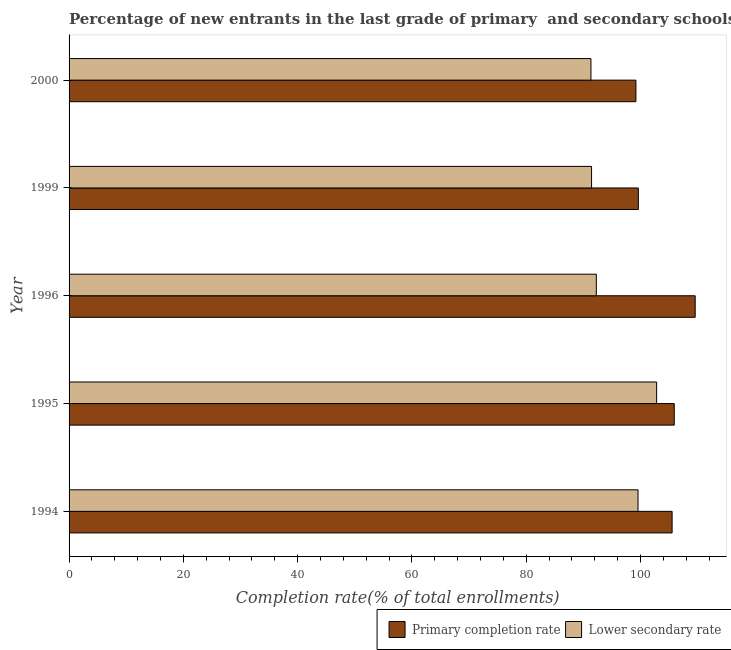How many different coloured bars are there?
Your answer should be compact. 2. Are the number of bars per tick equal to the number of legend labels?
Offer a very short reply. Yes. Are the number of bars on each tick of the Y-axis equal?
Offer a terse response. Yes. What is the label of the 1st group of bars from the top?
Your answer should be very brief. 2000. What is the completion rate in secondary schools in 1996?
Provide a succinct answer. 92.26. Across all years, what is the maximum completion rate in primary schools?
Ensure brevity in your answer.  109.56. Across all years, what is the minimum completion rate in secondary schools?
Offer a terse response. 91.32. In which year was the completion rate in secondary schools maximum?
Your answer should be compact. 1995. What is the total completion rate in primary schools in the graph?
Offer a terse response. 519.78. What is the difference between the completion rate in secondary schools in 1995 and that in 1999?
Ensure brevity in your answer.  11.38. What is the difference between the completion rate in secondary schools in 2000 and the completion rate in primary schools in 1994?
Your response must be concise. -14.2. What is the average completion rate in secondary schools per year?
Your answer should be compact. 95.48. In the year 2000, what is the difference between the completion rate in secondary schools and completion rate in primary schools?
Your response must be concise. -7.87. In how many years, is the completion rate in primary schools greater than 12 %?
Your answer should be very brief. 5. What is the ratio of the completion rate in primary schools in 1999 to that in 2000?
Provide a succinct answer. 1. Is the difference between the completion rate in primary schools in 1994 and 1996 greater than the difference between the completion rate in secondary schools in 1994 and 1996?
Make the answer very short. No. What is the difference between the highest and the second highest completion rate in primary schools?
Your response must be concise. 3.66. What is the difference between the highest and the lowest completion rate in secondary schools?
Provide a short and direct response. 11.49. Is the sum of the completion rate in secondary schools in 1994 and 2000 greater than the maximum completion rate in primary schools across all years?
Your answer should be compact. Yes. What does the 2nd bar from the top in 1996 represents?
Your response must be concise. Primary completion rate. What does the 2nd bar from the bottom in 1999 represents?
Ensure brevity in your answer.  Lower secondary rate. What is the difference between two consecutive major ticks on the X-axis?
Your answer should be compact. 20. Are the values on the major ticks of X-axis written in scientific E-notation?
Your answer should be very brief. No. Does the graph contain any zero values?
Offer a very short reply. No. Does the graph contain grids?
Your answer should be very brief. No. Where does the legend appear in the graph?
Offer a very short reply. Bottom right. How many legend labels are there?
Offer a terse response. 2. How are the legend labels stacked?
Provide a short and direct response. Horizontal. What is the title of the graph?
Provide a short and direct response. Percentage of new entrants in the last grade of primary  and secondary schools in Czech Republic. What is the label or title of the X-axis?
Keep it short and to the point. Completion rate(% of total enrollments). What is the label or title of the Y-axis?
Offer a terse response. Year. What is the Completion rate(% of total enrollments) in Primary completion rate in 1994?
Provide a succinct answer. 105.52. What is the Completion rate(% of total enrollments) in Lower secondary rate in 1994?
Your response must be concise. 99.56. What is the Completion rate(% of total enrollments) in Primary completion rate in 1995?
Ensure brevity in your answer.  105.9. What is the Completion rate(% of total enrollments) of Lower secondary rate in 1995?
Your response must be concise. 102.81. What is the Completion rate(% of total enrollments) in Primary completion rate in 1996?
Provide a succinct answer. 109.56. What is the Completion rate(% of total enrollments) of Lower secondary rate in 1996?
Keep it short and to the point. 92.26. What is the Completion rate(% of total enrollments) of Primary completion rate in 1999?
Provide a succinct answer. 99.61. What is the Completion rate(% of total enrollments) of Lower secondary rate in 1999?
Offer a very short reply. 91.43. What is the Completion rate(% of total enrollments) of Primary completion rate in 2000?
Give a very brief answer. 99.19. What is the Completion rate(% of total enrollments) in Lower secondary rate in 2000?
Give a very brief answer. 91.32. Across all years, what is the maximum Completion rate(% of total enrollments) in Primary completion rate?
Offer a terse response. 109.56. Across all years, what is the maximum Completion rate(% of total enrollments) of Lower secondary rate?
Provide a succinct answer. 102.81. Across all years, what is the minimum Completion rate(% of total enrollments) of Primary completion rate?
Your response must be concise. 99.19. Across all years, what is the minimum Completion rate(% of total enrollments) in Lower secondary rate?
Ensure brevity in your answer.  91.32. What is the total Completion rate(% of total enrollments) of Primary completion rate in the graph?
Your answer should be very brief. 519.78. What is the total Completion rate(% of total enrollments) in Lower secondary rate in the graph?
Make the answer very short. 477.38. What is the difference between the Completion rate(% of total enrollments) of Primary completion rate in 1994 and that in 1995?
Make the answer very short. -0.38. What is the difference between the Completion rate(% of total enrollments) in Lower secondary rate in 1994 and that in 1995?
Your answer should be very brief. -3.25. What is the difference between the Completion rate(% of total enrollments) in Primary completion rate in 1994 and that in 1996?
Offer a very short reply. -4.04. What is the difference between the Completion rate(% of total enrollments) in Lower secondary rate in 1994 and that in 1996?
Make the answer very short. 7.3. What is the difference between the Completion rate(% of total enrollments) of Primary completion rate in 1994 and that in 1999?
Provide a short and direct response. 5.91. What is the difference between the Completion rate(% of total enrollments) of Lower secondary rate in 1994 and that in 1999?
Provide a succinct answer. 8.13. What is the difference between the Completion rate(% of total enrollments) of Primary completion rate in 1994 and that in 2000?
Provide a succinct answer. 6.33. What is the difference between the Completion rate(% of total enrollments) of Lower secondary rate in 1994 and that in 2000?
Keep it short and to the point. 8.24. What is the difference between the Completion rate(% of total enrollments) of Primary completion rate in 1995 and that in 1996?
Offer a terse response. -3.66. What is the difference between the Completion rate(% of total enrollments) of Lower secondary rate in 1995 and that in 1996?
Offer a very short reply. 10.55. What is the difference between the Completion rate(% of total enrollments) of Primary completion rate in 1995 and that in 1999?
Keep it short and to the point. 6.29. What is the difference between the Completion rate(% of total enrollments) of Lower secondary rate in 1995 and that in 1999?
Offer a terse response. 11.38. What is the difference between the Completion rate(% of total enrollments) of Primary completion rate in 1995 and that in 2000?
Provide a short and direct response. 6.71. What is the difference between the Completion rate(% of total enrollments) of Lower secondary rate in 1995 and that in 2000?
Keep it short and to the point. 11.49. What is the difference between the Completion rate(% of total enrollments) of Primary completion rate in 1996 and that in 1999?
Make the answer very short. 9.95. What is the difference between the Completion rate(% of total enrollments) of Lower secondary rate in 1996 and that in 1999?
Your answer should be very brief. 0.83. What is the difference between the Completion rate(% of total enrollments) of Primary completion rate in 1996 and that in 2000?
Your answer should be very brief. 10.37. What is the difference between the Completion rate(% of total enrollments) of Lower secondary rate in 1996 and that in 2000?
Offer a terse response. 0.94. What is the difference between the Completion rate(% of total enrollments) in Primary completion rate in 1999 and that in 2000?
Give a very brief answer. 0.42. What is the difference between the Completion rate(% of total enrollments) of Lower secondary rate in 1999 and that in 2000?
Your answer should be very brief. 0.11. What is the difference between the Completion rate(% of total enrollments) in Primary completion rate in 1994 and the Completion rate(% of total enrollments) in Lower secondary rate in 1995?
Make the answer very short. 2.71. What is the difference between the Completion rate(% of total enrollments) of Primary completion rate in 1994 and the Completion rate(% of total enrollments) of Lower secondary rate in 1996?
Your answer should be very brief. 13.26. What is the difference between the Completion rate(% of total enrollments) of Primary completion rate in 1994 and the Completion rate(% of total enrollments) of Lower secondary rate in 1999?
Your response must be concise. 14.09. What is the difference between the Completion rate(% of total enrollments) of Primary completion rate in 1994 and the Completion rate(% of total enrollments) of Lower secondary rate in 2000?
Make the answer very short. 14.2. What is the difference between the Completion rate(% of total enrollments) of Primary completion rate in 1995 and the Completion rate(% of total enrollments) of Lower secondary rate in 1996?
Offer a terse response. 13.64. What is the difference between the Completion rate(% of total enrollments) of Primary completion rate in 1995 and the Completion rate(% of total enrollments) of Lower secondary rate in 1999?
Make the answer very short. 14.47. What is the difference between the Completion rate(% of total enrollments) of Primary completion rate in 1995 and the Completion rate(% of total enrollments) of Lower secondary rate in 2000?
Your answer should be very brief. 14.58. What is the difference between the Completion rate(% of total enrollments) in Primary completion rate in 1996 and the Completion rate(% of total enrollments) in Lower secondary rate in 1999?
Keep it short and to the point. 18.13. What is the difference between the Completion rate(% of total enrollments) in Primary completion rate in 1996 and the Completion rate(% of total enrollments) in Lower secondary rate in 2000?
Your answer should be very brief. 18.24. What is the difference between the Completion rate(% of total enrollments) in Primary completion rate in 1999 and the Completion rate(% of total enrollments) in Lower secondary rate in 2000?
Make the answer very short. 8.29. What is the average Completion rate(% of total enrollments) in Primary completion rate per year?
Provide a succinct answer. 103.96. What is the average Completion rate(% of total enrollments) of Lower secondary rate per year?
Provide a succinct answer. 95.48. In the year 1994, what is the difference between the Completion rate(% of total enrollments) in Primary completion rate and Completion rate(% of total enrollments) in Lower secondary rate?
Keep it short and to the point. 5.96. In the year 1995, what is the difference between the Completion rate(% of total enrollments) of Primary completion rate and Completion rate(% of total enrollments) of Lower secondary rate?
Make the answer very short. 3.09. In the year 1996, what is the difference between the Completion rate(% of total enrollments) in Primary completion rate and Completion rate(% of total enrollments) in Lower secondary rate?
Provide a succinct answer. 17.3. In the year 1999, what is the difference between the Completion rate(% of total enrollments) in Primary completion rate and Completion rate(% of total enrollments) in Lower secondary rate?
Your response must be concise. 8.18. In the year 2000, what is the difference between the Completion rate(% of total enrollments) of Primary completion rate and Completion rate(% of total enrollments) of Lower secondary rate?
Your answer should be compact. 7.87. What is the ratio of the Completion rate(% of total enrollments) in Primary completion rate in 1994 to that in 1995?
Provide a succinct answer. 1. What is the ratio of the Completion rate(% of total enrollments) of Lower secondary rate in 1994 to that in 1995?
Provide a succinct answer. 0.97. What is the ratio of the Completion rate(% of total enrollments) in Primary completion rate in 1994 to that in 1996?
Ensure brevity in your answer.  0.96. What is the ratio of the Completion rate(% of total enrollments) of Lower secondary rate in 1994 to that in 1996?
Offer a terse response. 1.08. What is the ratio of the Completion rate(% of total enrollments) in Primary completion rate in 1994 to that in 1999?
Offer a very short reply. 1.06. What is the ratio of the Completion rate(% of total enrollments) in Lower secondary rate in 1994 to that in 1999?
Make the answer very short. 1.09. What is the ratio of the Completion rate(% of total enrollments) in Primary completion rate in 1994 to that in 2000?
Give a very brief answer. 1.06. What is the ratio of the Completion rate(% of total enrollments) in Lower secondary rate in 1994 to that in 2000?
Your answer should be very brief. 1.09. What is the ratio of the Completion rate(% of total enrollments) of Primary completion rate in 1995 to that in 1996?
Offer a very short reply. 0.97. What is the ratio of the Completion rate(% of total enrollments) of Lower secondary rate in 1995 to that in 1996?
Offer a terse response. 1.11. What is the ratio of the Completion rate(% of total enrollments) in Primary completion rate in 1995 to that in 1999?
Make the answer very short. 1.06. What is the ratio of the Completion rate(% of total enrollments) of Lower secondary rate in 1995 to that in 1999?
Your answer should be compact. 1.12. What is the ratio of the Completion rate(% of total enrollments) in Primary completion rate in 1995 to that in 2000?
Provide a short and direct response. 1.07. What is the ratio of the Completion rate(% of total enrollments) of Lower secondary rate in 1995 to that in 2000?
Offer a terse response. 1.13. What is the ratio of the Completion rate(% of total enrollments) of Primary completion rate in 1996 to that in 1999?
Ensure brevity in your answer.  1.1. What is the ratio of the Completion rate(% of total enrollments) of Lower secondary rate in 1996 to that in 1999?
Your answer should be compact. 1.01. What is the ratio of the Completion rate(% of total enrollments) in Primary completion rate in 1996 to that in 2000?
Provide a short and direct response. 1.1. What is the ratio of the Completion rate(% of total enrollments) in Lower secondary rate in 1996 to that in 2000?
Your response must be concise. 1.01. What is the ratio of the Completion rate(% of total enrollments) in Primary completion rate in 1999 to that in 2000?
Your answer should be very brief. 1. What is the difference between the highest and the second highest Completion rate(% of total enrollments) of Primary completion rate?
Provide a succinct answer. 3.66. What is the difference between the highest and the second highest Completion rate(% of total enrollments) in Lower secondary rate?
Make the answer very short. 3.25. What is the difference between the highest and the lowest Completion rate(% of total enrollments) of Primary completion rate?
Your answer should be compact. 10.37. What is the difference between the highest and the lowest Completion rate(% of total enrollments) in Lower secondary rate?
Your answer should be very brief. 11.49. 